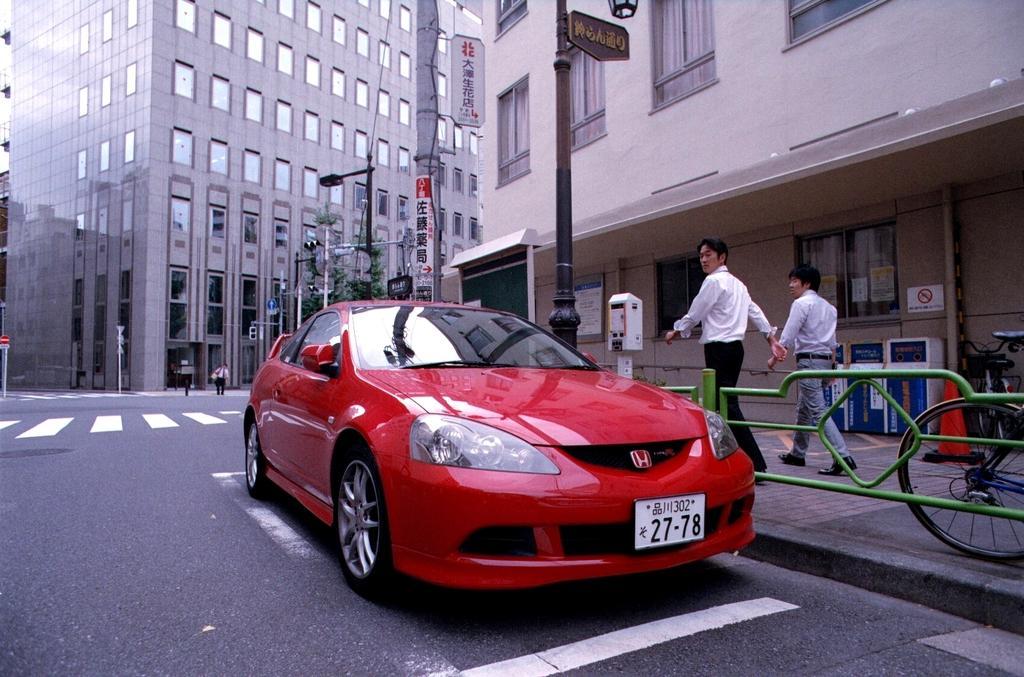Can you describe this image briefly? In this image there is a red color car on the road. Right side there is a fence on the pavement. Behind the fence there is bicycle, few poles attached with the boards and street lights are on the pavement. Right side two persons are walking on the pavement. Left side few persons are walking on the road. Background there are few buildings. 